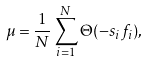<formula> <loc_0><loc_0><loc_500><loc_500>\mu = \frac { 1 } { N } \sum _ { i = 1 } ^ { N } \Theta ( - s _ { i } f _ { i } ) ,</formula> 